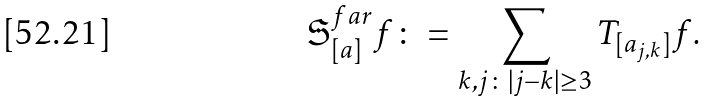Convert formula to latex. <formula><loc_0><loc_0><loc_500><loc_500>\mathfrak { S } _ { [ a ] } ^ { f a r } f \colon = \sum _ { k , j \colon | j - k | \geq 3 } { T _ { [ a _ { j , k } ] } f } .</formula> 